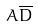Convert formula to latex. <formula><loc_0><loc_0><loc_500><loc_500>A \overline { D }</formula> 